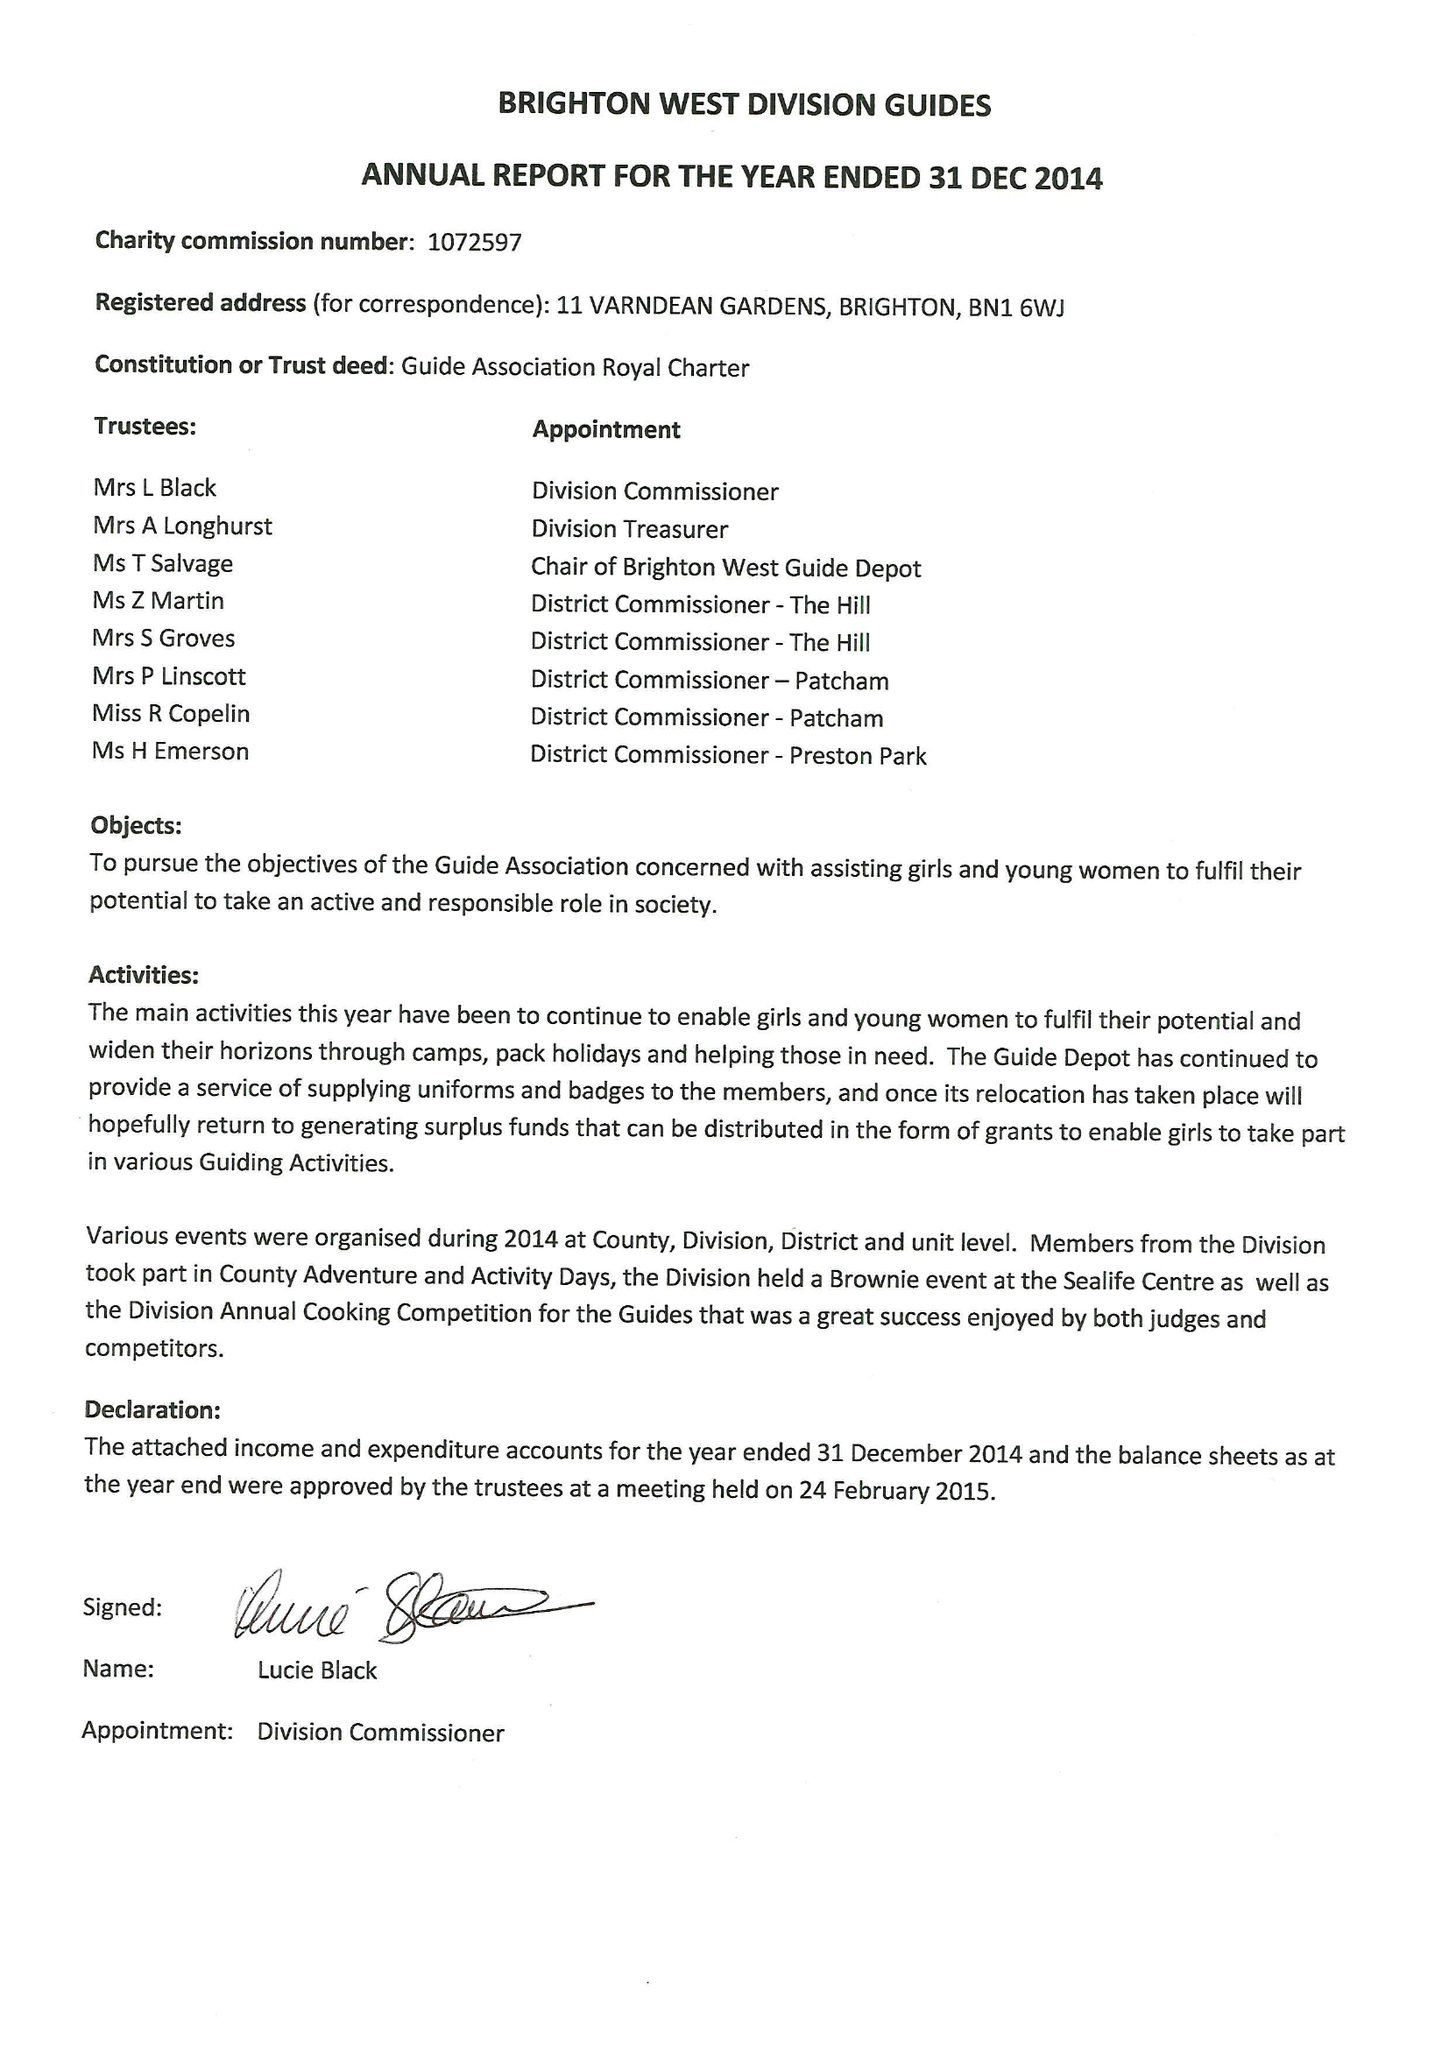What is the value for the income_annually_in_british_pounds?
Answer the question using a single word or phrase. 32246.00 